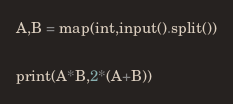<code> <loc_0><loc_0><loc_500><loc_500><_Python_>A,B = map(int,input().split())

print(A*B,2*(A+B))
</code> 